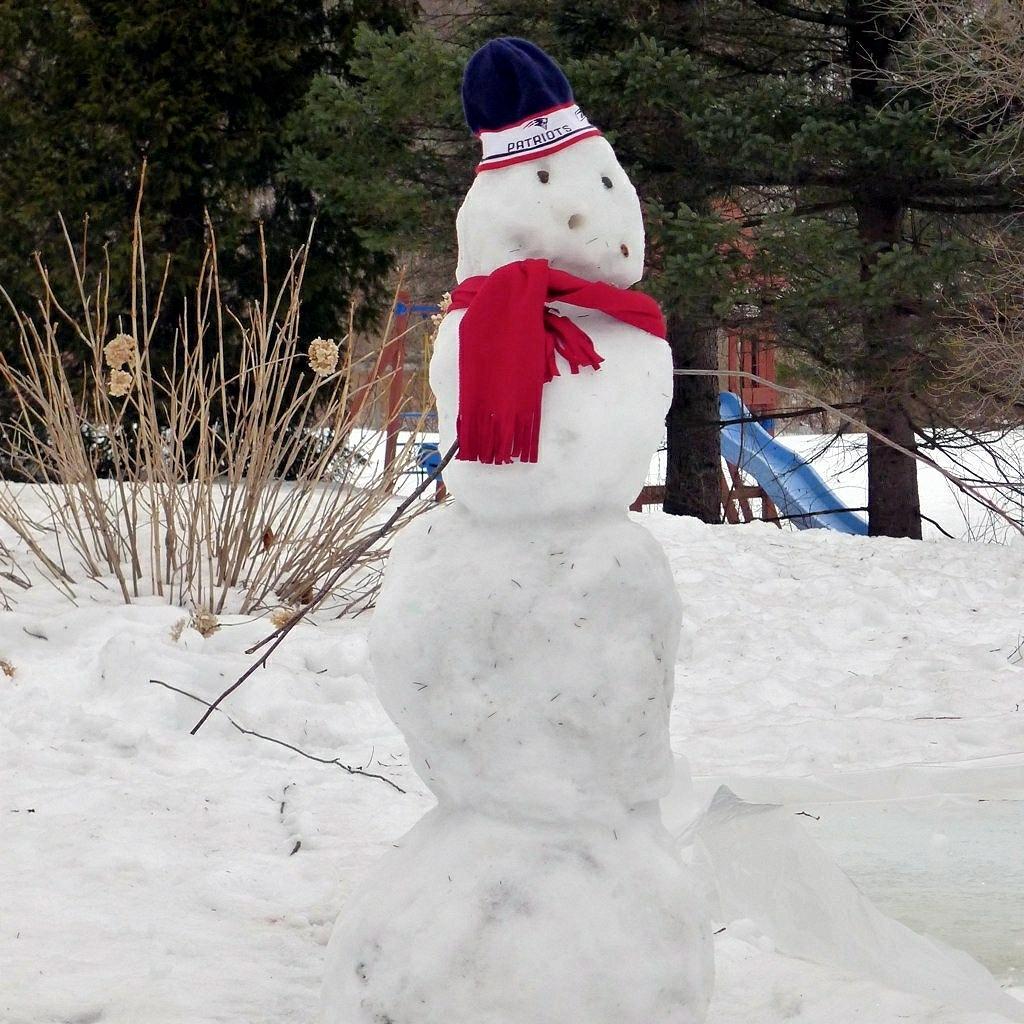Describe this image in one or two sentences. In the image we can see there is snowman standing on the ground and the ground is covered with snow. Behind there is dry plants and there are trees at the back. There is a slide kept on the ground. 